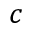Convert formula to latex. <formula><loc_0><loc_0><loc_500><loc_500>c</formula> 